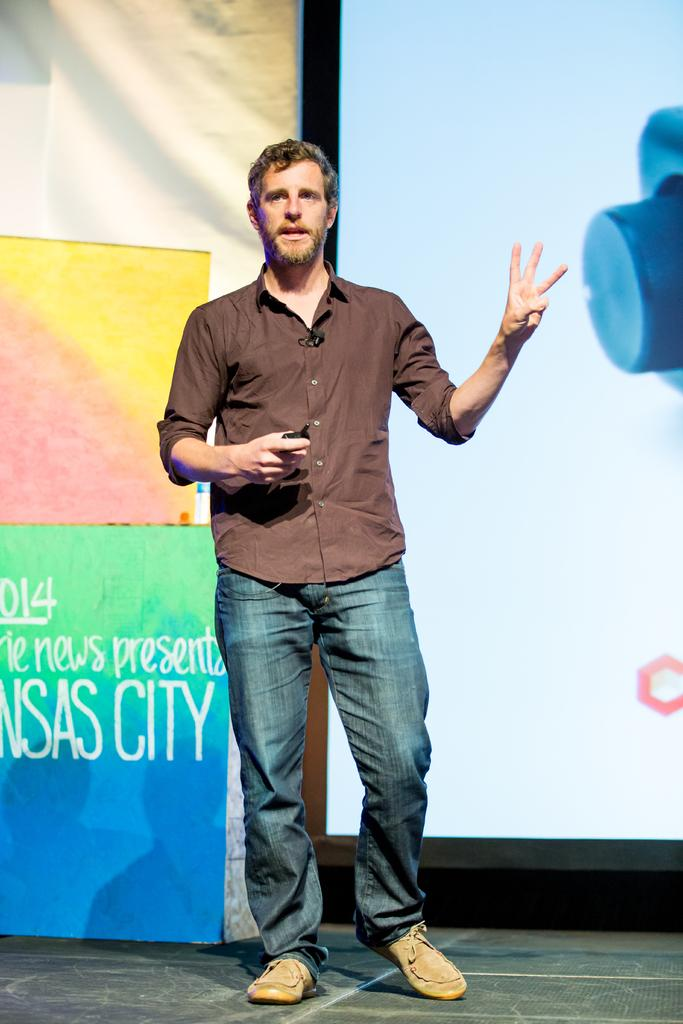What is happening on the stage in the image? There is a person on the stage in the image. What is the person holding? The person is holding an object. What can be seen on the screen in the image? There is a display on a screen in the image. What type of information is conveyed through the posters in the image? There are posters with text in the image. Is there a flame visible in the image? No, there is no flame present in the image. 